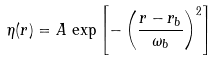Convert formula to latex. <formula><loc_0><loc_0><loc_500><loc_500>\eta ( r ) = A \, \exp \left [ - \left ( \frac { r - r _ { b } } { \omega _ { b } } \right ) ^ { 2 } \right ]</formula> 